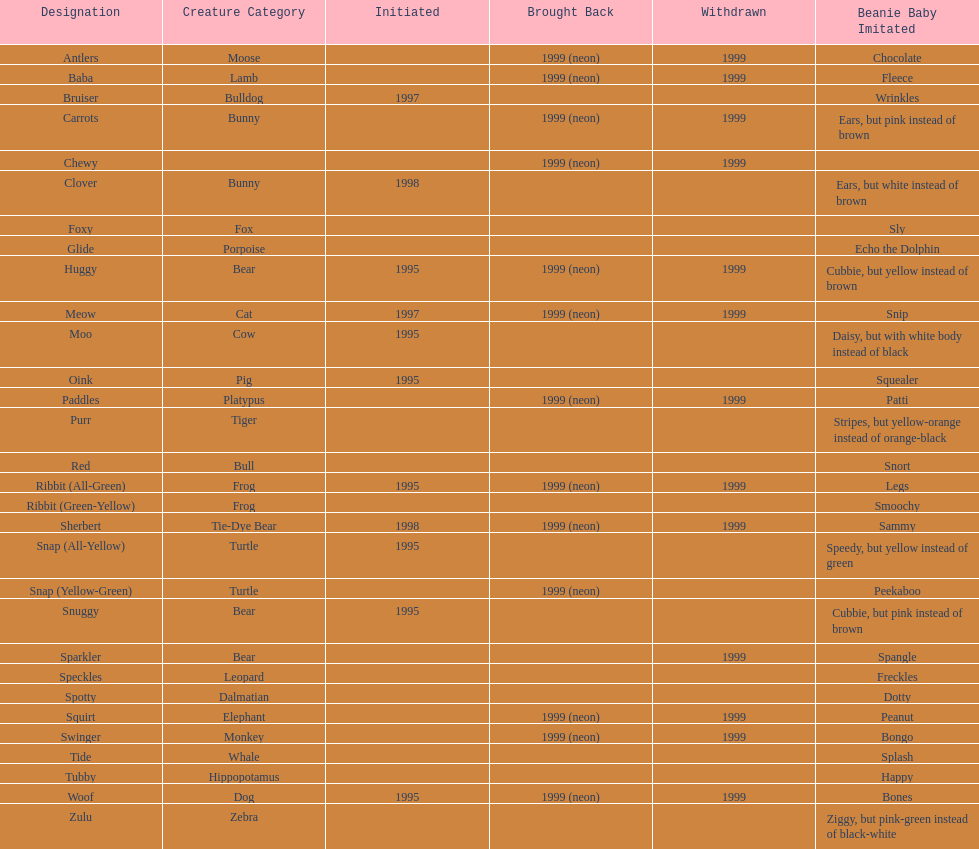What is the name of the pillow pal listed after clover? Foxy. Can you give me this table as a dict? {'header': ['Designation', 'Creature Category', 'Initiated', 'Brought Back', 'Withdrawn', 'Beanie Baby Imitated'], 'rows': [['Antlers', 'Moose', '', '1999 (neon)', '1999', 'Chocolate'], ['Baba', 'Lamb', '', '1999 (neon)', '1999', 'Fleece'], ['Bruiser', 'Bulldog', '1997', '', '', 'Wrinkles'], ['Carrots', 'Bunny', '', '1999 (neon)', '1999', 'Ears, but pink instead of brown'], ['Chewy', '', '', '1999 (neon)', '1999', ''], ['Clover', 'Bunny', '1998', '', '', 'Ears, but white instead of brown'], ['Foxy', 'Fox', '', '', '', 'Sly'], ['Glide', 'Porpoise', '', '', '', 'Echo the Dolphin'], ['Huggy', 'Bear', '1995', '1999 (neon)', '1999', 'Cubbie, but yellow instead of brown'], ['Meow', 'Cat', '1997', '1999 (neon)', '1999', 'Snip'], ['Moo', 'Cow', '1995', '', '', 'Daisy, but with white body instead of black'], ['Oink', 'Pig', '1995', '', '', 'Squealer'], ['Paddles', 'Platypus', '', '1999 (neon)', '1999', 'Patti'], ['Purr', 'Tiger', '', '', '', 'Stripes, but yellow-orange instead of orange-black'], ['Red', 'Bull', '', '', '', 'Snort'], ['Ribbit (All-Green)', 'Frog', '1995', '1999 (neon)', '1999', 'Legs'], ['Ribbit (Green-Yellow)', 'Frog', '', '', '', 'Smoochy'], ['Sherbert', 'Tie-Dye Bear', '1998', '1999 (neon)', '1999', 'Sammy'], ['Snap (All-Yellow)', 'Turtle', '1995', '', '', 'Speedy, but yellow instead of green'], ['Snap (Yellow-Green)', 'Turtle', '', '1999 (neon)', '', 'Peekaboo'], ['Snuggy', 'Bear', '1995', '', '', 'Cubbie, but pink instead of brown'], ['Sparkler', 'Bear', '', '', '1999', 'Spangle'], ['Speckles', 'Leopard', '', '', '', 'Freckles'], ['Spotty', 'Dalmatian', '', '', '', 'Dotty'], ['Squirt', 'Elephant', '', '1999 (neon)', '1999', 'Peanut'], ['Swinger', 'Monkey', '', '1999 (neon)', '1999', 'Bongo'], ['Tide', 'Whale', '', '', '', 'Splash'], ['Tubby', 'Hippopotamus', '', '', '', 'Happy'], ['Woof', 'Dog', '1995', '1999 (neon)', '1999', 'Bones'], ['Zulu', 'Zebra', '', '', '', 'Ziggy, but pink-green instead of black-white']]} 